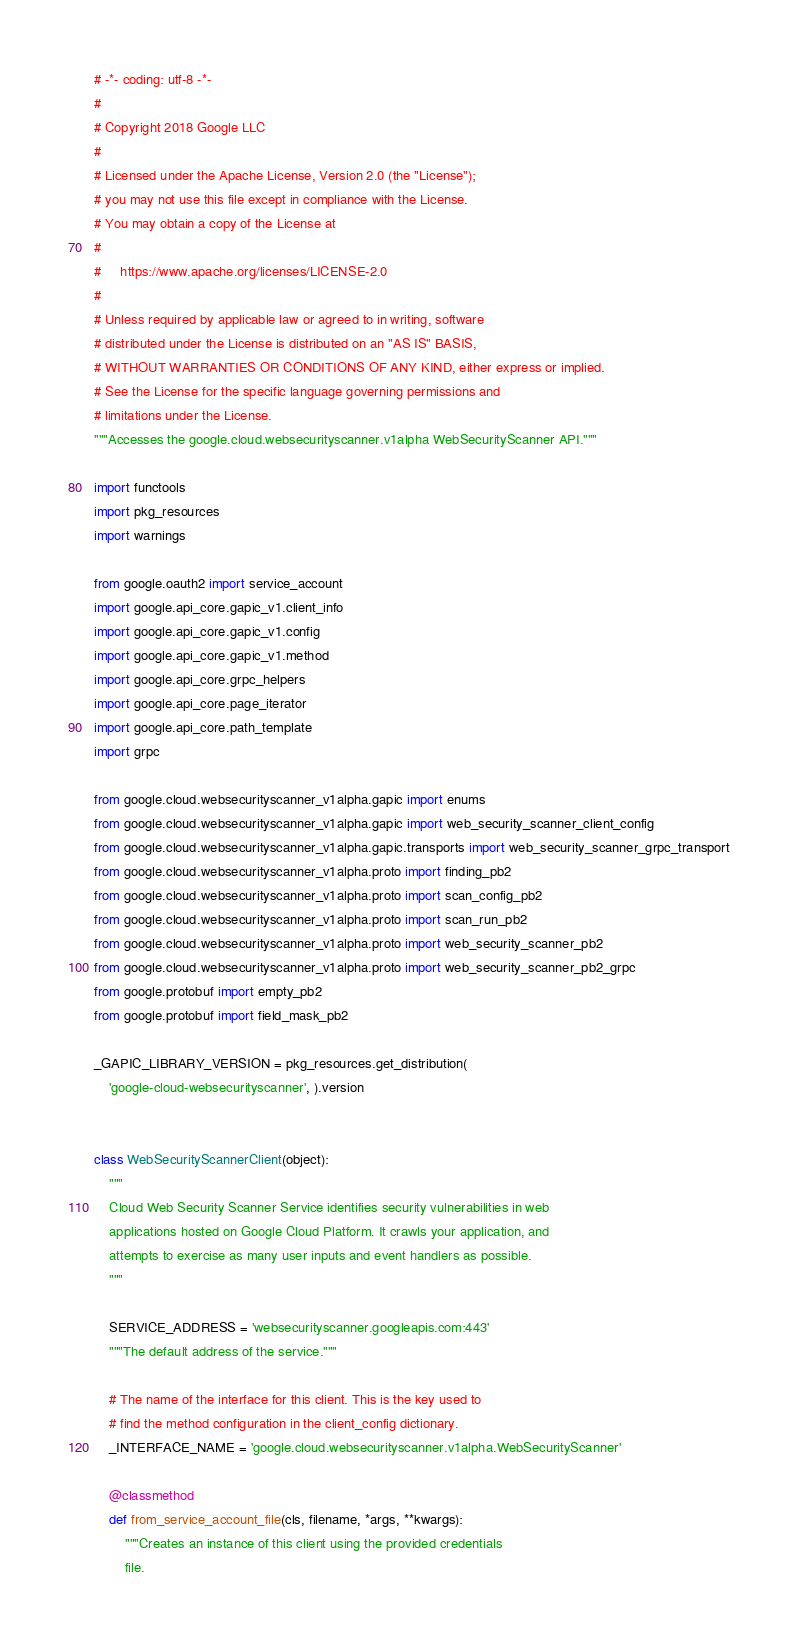<code> <loc_0><loc_0><loc_500><loc_500><_Python_># -*- coding: utf-8 -*-
#
# Copyright 2018 Google LLC
#
# Licensed under the Apache License, Version 2.0 (the "License");
# you may not use this file except in compliance with the License.
# You may obtain a copy of the License at
#
#     https://www.apache.org/licenses/LICENSE-2.0
#
# Unless required by applicable law or agreed to in writing, software
# distributed under the License is distributed on an "AS IS" BASIS,
# WITHOUT WARRANTIES OR CONDITIONS OF ANY KIND, either express or implied.
# See the License for the specific language governing permissions and
# limitations under the License.
"""Accesses the google.cloud.websecurityscanner.v1alpha WebSecurityScanner API."""

import functools
import pkg_resources
import warnings

from google.oauth2 import service_account
import google.api_core.gapic_v1.client_info
import google.api_core.gapic_v1.config
import google.api_core.gapic_v1.method
import google.api_core.grpc_helpers
import google.api_core.page_iterator
import google.api_core.path_template
import grpc

from google.cloud.websecurityscanner_v1alpha.gapic import enums
from google.cloud.websecurityscanner_v1alpha.gapic import web_security_scanner_client_config
from google.cloud.websecurityscanner_v1alpha.gapic.transports import web_security_scanner_grpc_transport
from google.cloud.websecurityscanner_v1alpha.proto import finding_pb2
from google.cloud.websecurityscanner_v1alpha.proto import scan_config_pb2
from google.cloud.websecurityscanner_v1alpha.proto import scan_run_pb2
from google.cloud.websecurityscanner_v1alpha.proto import web_security_scanner_pb2
from google.cloud.websecurityscanner_v1alpha.proto import web_security_scanner_pb2_grpc
from google.protobuf import empty_pb2
from google.protobuf import field_mask_pb2

_GAPIC_LIBRARY_VERSION = pkg_resources.get_distribution(
    'google-cloud-websecurityscanner', ).version


class WebSecurityScannerClient(object):
    """
    Cloud Web Security Scanner Service identifies security vulnerabilities in web
    applications hosted on Google Cloud Platform. It crawls your application, and
    attempts to exercise as many user inputs and event handlers as possible.
    """

    SERVICE_ADDRESS = 'websecurityscanner.googleapis.com:443'
    """The default address of the service."""

    # The name of the interface for this client. This is the key used to
    # find the method configuration in the client_config dictionary.
    _INTERFACE_NAME = 'google.cloud.websecurityscanner.v1alpha.WebSecurityScanner'

    @classmethod
    def from_service_account_file(cls, filename, *args, **kwargs):
        """Creates an instance of this client using the provided credentials
        file.
</code> 